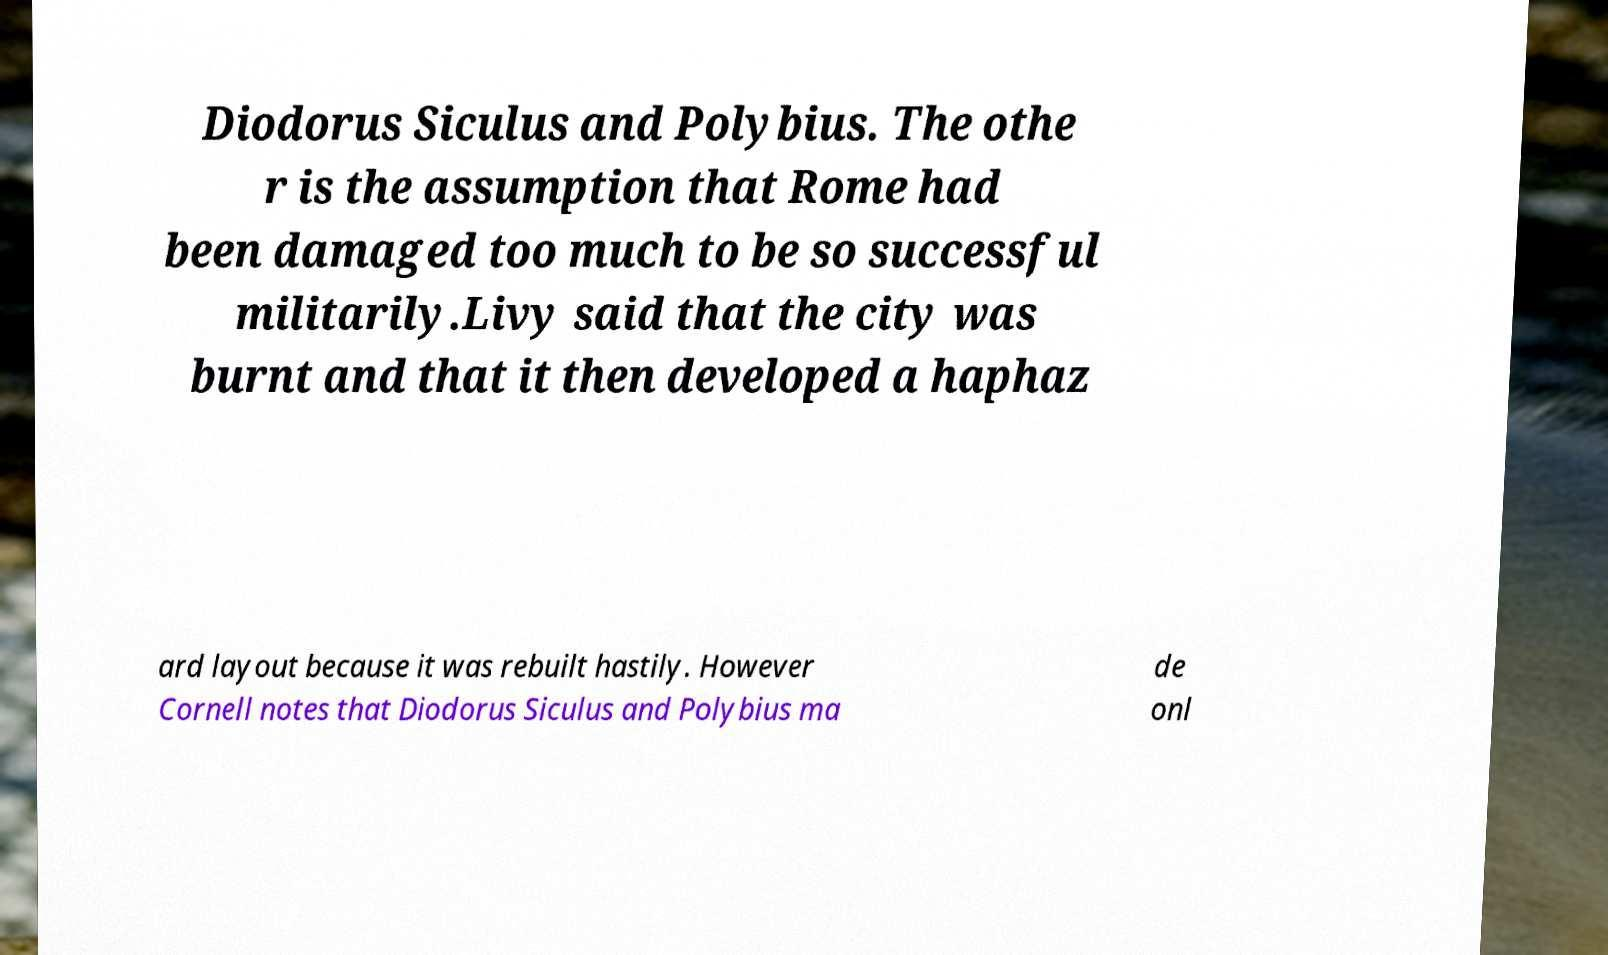Please identify and transcribe the text found in this image. Diodorus Siculus and Polybius. The othe r is the assumption that Rome had been damaged too much to be so successful militarily.Livy said that the city was burnt and that it then developed a haphaz ard layout because it was rebuilt hastily. However Cornell notes that Diodorus Siculus and Polybius ma de onl 